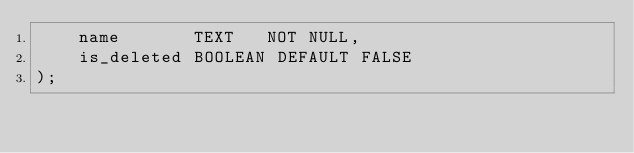Convert code to text. <code><loc_0><loc_0><loc_500><loc_500><_SQL_>	name       TEXT   NOT NULL,
	is_deleted BOOLEAN DEFAULT FALSE
);</code> 